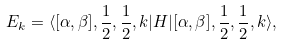Convert formula to latex. <formula><loc_0><loc_0><loc_500><loc_500>E _ { k } = \langle [ \alpha , \beta ] , \frac { 1 } { 2 } , \frac { 1 } { 2 } , { k } | H | [ \alpha , \beta ] , \frac { 1 } { 2 } , \frac { 1 } { 2 } , { k } \rangle ,</formula> 